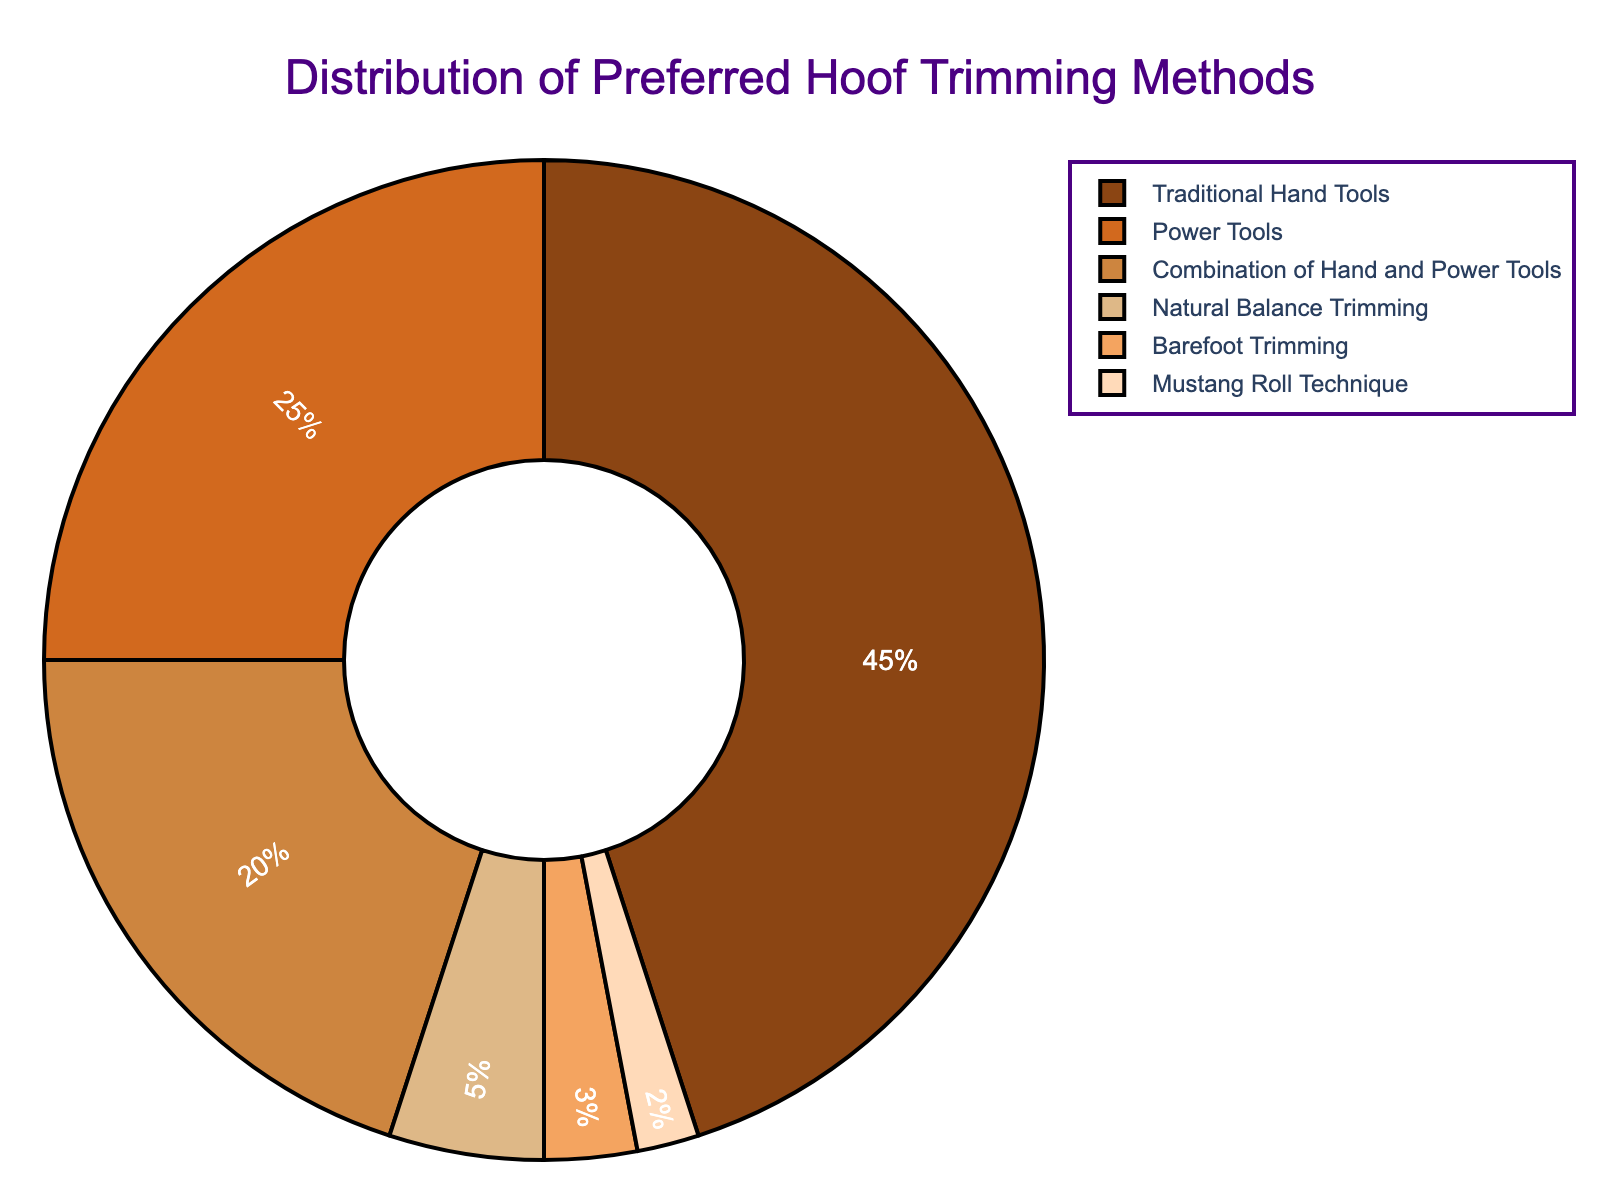What is the most preferred hoof trimming method among professional farriers? The slice representing the "Traditional Hand Tools" method is the largest piece of the pie chart.
Answer: Traditional Hand Tools Which hoof trimming method is the least preferred? The smallest slice of the pie chart corresponds to the "Mustang Roll Technique" with the smallest percentage.
Answer: Mustang Roll Technique What combined percentage of farriers prefer using only power tools or a combination of hand and power tools? Add the percentages for "Power Tools" and "Combination of Hand and Power Tools": 25% + 20% = 45%.
Answer: 45% Which method is preferred by more farriers, Barefoot Trimming or Natural Balance Trimming? Compare the sizes of the slices; "Natural Balance Trimming" has a larger percentage (5%) than "Barefoot Trimming" (3%).
Answer: Natural Balance Trimming How much more popular is the Traditional Hand Tools method compared to the Natural Balance Trimming method? Subtract the percentage of Natural Balance Trimming from Traditional Hand Tools: 45% - 5% = 40%.
Answer: 40% What percentage of farriers prefer methods that involve power tools in any form (either solely or in combination)? Sum the percentages of "Power Tools" and "Combination of Hand and Power Tools": 25% + 20% = 45%.
Answer: 45% How many methods have a percentage of 5% or lower? Identify all the methods with 5% or less: "Natural Balance Trimming (5%)", "Barefoot Trimming (3%)", "Mustang Roll Technique (2%)". There are three such methods.
Answer: 3 Which method(s) involve using hand tools in any form? Identify methods including hand tools: "Traditional Hand Tools (45%)" and "Combination of Hand and Power Tools (20%)". Combine their percentages (45% + 20% = 65%).
Answer: Traditional Hand Tools, Combination of Hand and Power Tools Is the combination of hand and power tools method more or less popular than using just power tools? The percentage for "Combination of Hand and Power Tools" (20%) is less than "Power Tools" (25%).
Answer: Less Calculate the total percentage of farriers who prefer methods other than the top two preferred methods. First, find the top two methods: "Traditional Hand Tools (45%)" and "Power Tools (25%)". Then sum their percentages (45% + 25% = 70%). Subtract from 100% to get remaining methods' percentage: 100% - 70% = 30%.
Answer: 30% 